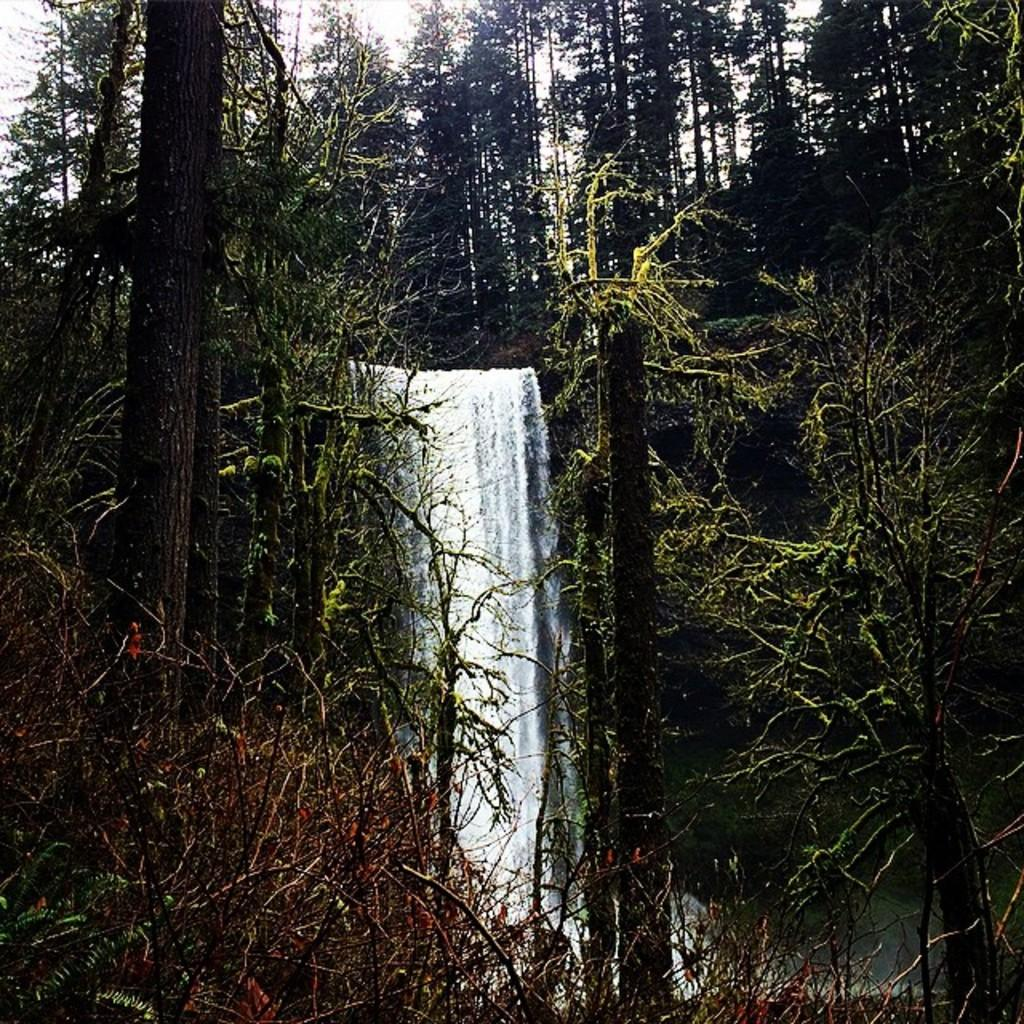What natural feature is the main subject of the image? There is a waterfall in the image. What type of vegetation can be seen in the image? There are many trees in the image. What type of zipper can be seen on the leg of the waterfall in the image? There is no zipper or leg present in the image; it features a waterfall and trees. 